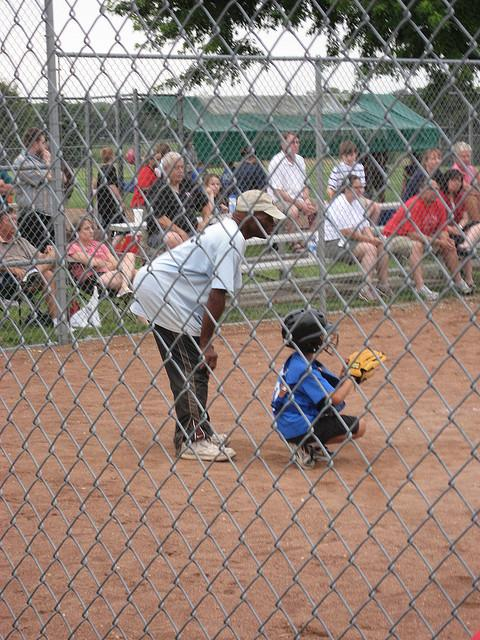How are the people in the stands here likely related to the players on the field here? parents 